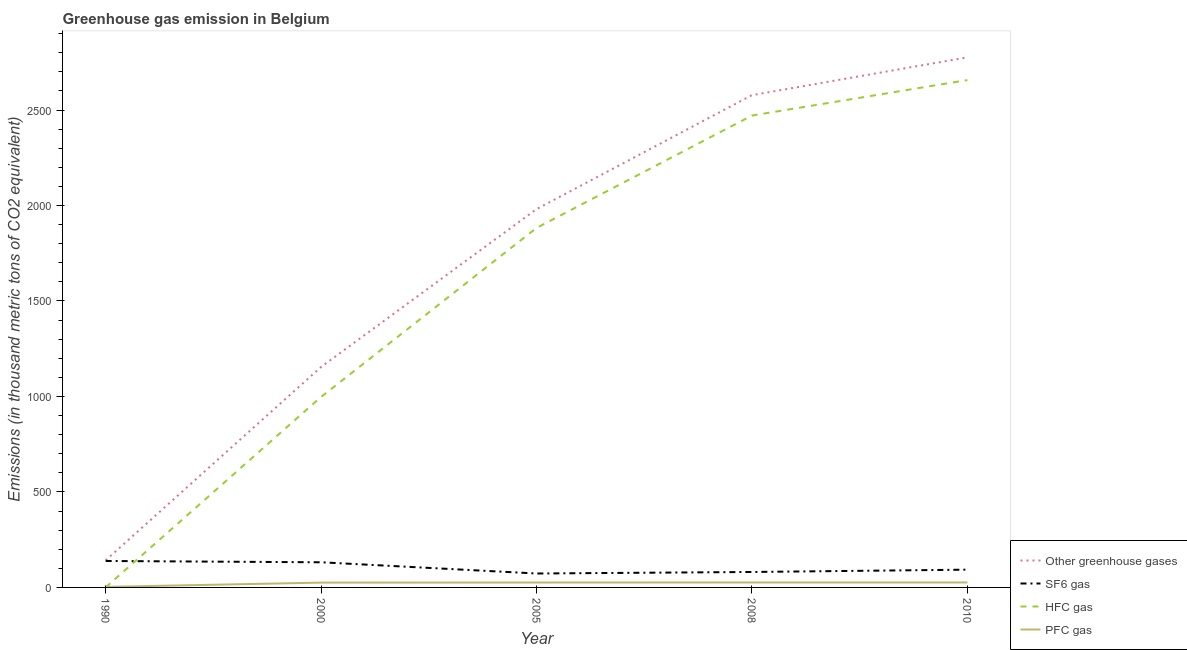How many different coloured lines are there?
Your answer should be compact. 4. Across all years, what is the maximum emission of sf6 gas?
Provide a short and direct response. 138.5. Across all years, what is the minimum emission of hfc gas?
Your answer should be very brief. 0.5. What is the total emission of sf6 gas in the graph?
Your answer should be very brief. 517. What is the difference between the emission of greenhouse gases in 2005 and that in 2008?
Offer a terse response. -596.8. What is the difference between the emission of pfc gas in 2005 and the emission of sf6 gas in 2010?
Offer a very short reply. -67.3. What is the average emission of pfc gas per year?
Keep it short and to the point. 21.16. In the year 1990, what is the difference between the emission of hfc gas and emission of greenhouse gases?
Make the answer very short. -141.4. In how many years, is the emission of greenhouse gases greater than 1600 thousand metric tons?
Provide a short and direct response. 3. What is the ratio of the emission of greenhouse gases in 2008 to that in 2010?
Your response must be concise. 0.93. Is the emission of greenhouse gases in 1990 less than that in 2005?
Offer a very short reply. Yes. What is the difference between the highest and the second highest emission of hfc gas?
Your answer should be very brief. 185.9. What is the difference between the highest and the lowest emission of greenhouse gases?
Make the answer very short. 2634.1. In how many years, is the emission of greenhouse gases greater than the average emission of greenhouse gases taken over all years?
Your answer should be very brief. 3. Is the sum of the emission of sf6 gas in 2005 and 2008 greater than the maximum emission of pfc gas across all years?
Your answer should be compact. Yes. Is it the case that in every year, the sum of the emission of pfc gas and emission of sf6 gas is greater than the sum of emission of greenhouse gases and emission of hfc gas?
Your answer should be compact. No. Is the emission of sf6 gas strictly less than the emission of pfc gas over the years?
Keep it short and to the point. No. How many lines are there?
Offer a terse response. 4. What is the difference between two consecutive major ticks on the Y-axis?
Offer a very short reply. 500. Does the graph contain grids?
Your answer should be compact. No. How are the legend labels stacked?
Keep it short and to the point. Vertical. What is the title of the graph?
Ensure brevity in your answer.  Greenhouse gas emission in Belgium. Does "Overall level" appear as one of the legend labels in the graph?
Give a very brief answer. No. What is the label or title of the X-axis?
Your answer should be very brief. Year. What is the label or title of the Y-axis?
Offer a terse response. Emissions (in thousand metric tons of CO2 equivalent). What is the Emissions (in thousand metric tons of CO2 equivalent) in Other greenhouse gases in 1990?
Ensure brevity in your answer.  141.9. What is the Emissions (in thousand metric tons of CO2 equivalent) of SF6 gas in 1990?
Provide a short and direct response. 138.5. What is the Emissions (in thousand metric tons of CO2 equivalent) of PFC gas in 1990?
Your response must be concise. 2.9. What is the Emissions (in thousand metric tons of CO2 equivalent) in Other greenhouse gases in 2000?
Your answer should be compact. 1154.6. What is the Emissions (in thousand metric tons of CO2 equivalent) in SF6 gas in 2000?
Your response must be concise. 131.7. What is the Emissions (in thousand metric tons of CO2 equivalent) of HFC gas in 2000?
Offer a very short reply. 997.7. What is the Emissions (in thousand metric tons of CO2 equivalent) of PFC gas in 2000?
Your response must be concise. 25.2. What is the Emissions (in thousand metric tons of CO2 equivalent) of Other greenhouse gases in 2005?
Ensure brevity in your answer.  1981.2. What is the Emissions (in thousand metric tons of CO2 equivalent) in SF6 gas in 2005?
Your answer should be very brief. 72.9. What is the Emissions (in thousand metric tons of CO2 equivalent) in HFC gas in 2005?
Keep it short and to the point. 1882.6. What is the Emissions (in thousand metric tons of CO2 equivalent) in PFC gas in 2005?
Provide a short and direct response. 25.7. What is the Emissions (in thousand metric tons of CO2 equivalent) in Other greenhouse gases in 2008?
Give a very brief answer. 2578. What is the Emissions (in thousand metric tons of CO2 equivalent) in SF6 gas in 2008?
Provide a short and direct response. 80.9. What is the Emissions (in thousand metric tons of CO2 equivalent) of HFC gas in 2008?
Your response must be concise. 2471.1. What is the Emissions (in thousand metric tons of CO2 equivalent) of Other greenhouse gases in 2010?
Ensure brevity in your answer.  2776. What is the Emissions (in thousand metric tons of CO2 equivalent) of SF6 gas in 2010?
Provide a succinct answer. 93. What is the Emissions (in thousand metric tons of CO2 equivalent) in HFC gas in 2010?
Ensure brevity in your answer.  2657. Across all years, what is the maximum Emissions (in thousand metric tons of CO2 equivalent) of Other greenhouse gases?
Provide a short and direct response. 2776. Across all years, what is the maximum Emissions (in thousand metric tons of CO2 equivalent) of SF6 gas?
Ensure brevity in your answer.  138.5. Across all years, what is the maximum Emissions (in thousand metric tons of CO2 equivalent) of HFC gas?
Provide a short and direct response. 2657. Across all years, what is the maximum Emissions (in thousand metric tons of CO2 equivalent) in PFC gas?
Your answer should be very brief. 26. Across all years, what is the minimum Emissions (in thousand metric tons of CO2 equivalent) of Other greenhouse gases?
Offer a terse response. 141.9. Across all years, what is the minimum Emissions (in thousand metric tons of CO2 equivalent) in SF6 gas?
Offer a terse response. 72.9. What is the total Emissions (in thousand metric tons of CO2 equivalent) in Other greenhouse gases in the graph?
Give a very brief answer. 8631.7. What is the total Emissions (in thousand metric tons of CO2 equivalent) of SF6 gas in the graph?
Ensure brevity in your answer.  517. What is the total Emissions (in thousand metric tons of CO2 equivalent) in HFC gas in the graph?
Provide a succinct answer. 8008.9. What is the total Emissions (in thousand metric tons of CO2 equivalent) of PFC gas in the graph?
Provide a short and direct response. 105.8. What is the difference between the Emissions (in thousand metric tons of CO2 equivalent) of Other greenhouse gases in 1990 and that in 2000?
Your answer should be very brief. -1012.7. What is the difference between the Emissions (in thousand metric tons of CO2 equivalent) of HFC gas in 1990 and that in 2000?
Your answer should be compact. -997.2. What is the difference between the Emissions (in thousand metric tons of CO2 equivalent) of PFC gas in 1990 and that in 2000?
Give a very brief answer. -22.3. What is the difference between the Emissions (in thousand metric tons of CO2 equivalent) in Other greenhouse gases in 1990 and that in 2005?
Provide a short and direct response. -1839.3. What is the difference between the Emissions (in thousand metric tons of CO2 equivalent) of SF6 gas in 1990 and that in 2005?
Provide a short and direct response. 65.6. What is the difference between the Emissions (in thousand metric tons of CO2 equivalent) in HFC gas in 1990 and that in 2005?
Keep it short and to the point. -1882.1. What is the difference between the Emissions (in thousand metric tons of CO2 equivalent) in PFC gas in 1990 and that in 2005?
Your response must be concise. -22.8. What is the difference between the Emissions (in thousand metric tons of CO2 equivalent) in Other greenhouse gases in 1990 and that in 2008?
Give a very brief answer. -2436.1. What is the difference between the Emissions (in thousand metric tons of CO2 equivalent) of SF6 gas in 1990 and that in 2008?
Provide a succinct answer. 57.6. What is the difference between the Emissions (in thousand metric tons of CO2 equivalent) of HFC gas in 1990 and that in 2008?
Keep it short and to the point. -2470.6. What is the difference between the Emissions (in thousand metric tons of CO2 equivalent) of PFC gas in 1990 and that in 2008?
Provide a short and direct response. -23.1. What is the difference between the Emissions (in thousand metric tons of CO2 equivalent) of Other greenhouse gases in 1990 and that in 2010?
Your answer should be compact. -2634.1. What is the difference between the Emissions (in thousand metric tons of CO2 equivalent) of SF6 gas in 1990 and that in 2010?
Keep it short and to the point. 45.5. What is the difference between the Emissions (in thousand metric tons of CO2 equivalent) in HFC gas in 1990 and that in 2010?
Your answer should be very brief. -2656.5. What is the difference between the Emissions (in thousand metric tons of CO2 equivalent) in PFC gas in 1990 and that in 2010?
Ensure brevity in your answer.  -23.1. What is the difference between the Emissions (in thousand metric tons of CO2 equivalent) of Other greenhouse gases in 2000 and that in 2005?
Keep it short and to the point. -826.6. What is the difference between the Emissions (in thousand metric tons of CO2 equivalent) in SF6 gas in 2000 and that in 2005?
Keep it short and to the point. 58.8. What is the difference between the Emissions (in thousand metric tons of CO2 equivalent) in HFC gas in 2000 and that in 2005?
Your answer should be very brief. -884.9. What is the difference between the Emissions (in thousand metric tons of CO2 equivalent) in Other greenhouse gases in 2000 and that in 2008?
Offer a terse response. -1423.4. What is the difference between the Emissions (in thousand metric tons of CO2 equivalent) in SF6 gas in 2000 and that in 2008?
Make the answer very short. 50.8. What is the difference between the Emissions (in thousand metric tons of CO2 equivalent) in HFC gas in 2000 and that in 2008?
Your answer should be very brief. -1473.4. What is the difference between the Emissions (in thousand metric tons of CO2 equivalent) of PFC gas in 2000 and that in 2008?
Give a very brief answer. -0.8. What is the difference between the Emissions (in thousand metric tons of CO2 equivalent) in Other greenhouse gases in 2000 and that in 2010?
Provide a succinct answer. -1621.4. What is the difference between the Emissions (in thousand metric tons of CO2 equivalent) in SF6 gas in 2000 and that in 2010?
Keep it short and to the point. 38.7. What is the difference between the Emissions (in thousand metric tons of CO2 equivalent) of HFC gas in 2000 and that in 2010?
Provide a short and direct response. -1659.3. What is the difference between the Emissions (in thousand metric tons of CO2 equivalent) of Other greenhouse gases in 2005 and that in 2008?
Your response must be concise. -596.8. What is the difference between the Emissions (in thousand metric tons of CO2 equivalent) in SF6 gas in 2005 and that in 2008?
Offer a very short reply. -8. What is the difference between the Emissions (in thousand metric tons of CO2 equivalent) of HFC gas in 2005 and that in 2008?
Your answer should be compact. -588.5. What is the difference between the Emissions (in thousand metric tons of CO2 equivalent) of Other greenhouse gases in 2005 and that in 2010?
Offer a terse response. -794.8. What is the difference between the Emissions (in thousand metric tons of CO2 equivalent) of SF6 gas in 2005 and that in 2010?
Provide a succinct answer. -20.1. What is the difference between the Emissions (in thousand metric tons of CO2 equivalent) of HFC gas in 2005 and that in 2010?
Offer a terse response. -774.4. What is the difference between the Emissions (in thousand metric tons of CO2 equivalent) of PFC gas in 2005 and that in 2010?
Your answer should be very brief. -0.3. What is the difference between the Emissions (in thousand metric tons of CO2 equivalent) of Other greenhouse gases in 2008 and that in 2010?
Your answer should be compact. -198. What is the difference between the Emissions (in thousand metric tons of CO2 equivalent) in HFC gas in 2008 and that in 2010?
Your response must be concise. -185.9. What is the difference between the Emissions (in thousand metric tons of CO2 equivalent) of PFC gas in 2008 and that in 2010?
Offer a terse response. 0. What is the difference between the Emissions (in thousand metric tons of CO2 equivalent) in Other greenhouse gases in 1990 and the Emissions (in thousand metric tons of CO2 equivalent) in HFC gas in 2000?
Give a very brief answer. -855.8. What is the difference between the Emissions (in thousand metric tons of CO2 equivalent) of Other greenhouse gases in 1990 and the Emissions (in thousand metric tons of CO2 equivalent) of PFC gas in 2000?
Make the answer very short. 116.7. What is the difference between the Emissions (in thousand metric tons of CO2 equivalent) in SF6 gas in 1990 and the Emissions (in thousand metric tons of CO2 equivalent) in HFC gas in 2000?
Give a very brief answer. -859.2. What is the difference between the Emissions (in thousand metric tons of CO2 equivalent) of SF6 gas in 1990 and the Emissions (in thousand metric tons of CO2 equivalent) of PFC gas in 2000?
Keep it short and to the point. 113.3. What is the difference between the Emissions (in thousand metric tons of CO2 equivalent) of HFC gas in 1990 and the Emissions (in thousand metric tons of CO2 equivalent) of PFC gas in 2000?
Offer a terse response. -24.7. What is the difference between the Emissions (in thousand metric tons of CO2 equivalent) of Other greenhouse gases in 1990 and the Emissions (in thousand metric tons of CO2 equivalent) of HFC gas in 2005?
Ensure brevity in your answer.  -1740.7. What is the difference between the Emissions (in thousand metric tons of CO2 equivalent) in Other greenhouse gases in 1990 and the Emissions (in thousand metric tons of CO2 equivalent) in PFC gas in 2005?
Give a very brief answer. 116.2. What is the difference between the Emissions (in thousand metric tons of CO2 equivalent) in SF6 gas in 1990 and the Emissions (in thousand metric tons of CO2 equivalent) in HFC gas in 2005?
Provide a short and direct response. -1744.1. What is the difference between the Emissions (in thousand metric tons of CO2 equivalent) in SF6 gas in 1990 and the Emissions (in thousand metric tons of CO2 equivalent) in PFC gas in 2005?
Offer a very short reply. 112.8. What is the difference between the Emissions (in thousand metric tons of CO2 equivalent) of HFC gas in 1990 and the Emissions (in thousand metric tons of CO2 equivalent) of PFC gas in 2005?
Give a very brief answer. -25.2. What is the difference between the Emissions (in thousand metric tons of CO2 equivalent) in Other greenhouse gases in 1990 and the Emissions (in thousand metric tons of CO2 equivalent) in HFC gas in 2008?
Provide a short and direct response. -2329.2. What is the difference between the Emissions (in thousand metric tons of CO2 equivalent) in Other greenhouse gases in 1990 and the Emissions (in thousand metric tons of CO2 equivalent) in PFC gas in 2008?
Offer a terse response. 115.9. What is the difference between the Emissions (in thousand metric tons of CO2 equivalent) in SF6 gas in 1990 and the Emissions (in thousand metric tons of CO2 equivalent) in HFC gas in 2008?
Provide a short and direct response. -2332.6. What is the difference between the Emissions (in thousand metric tons of CO2 equivalent) in SF6 gas in 1990 and the Emissions (in thousand metric tons of CO2 equivalent) in PFC gas in 2008?
Offer a terse response. 112.5. What is the difference between the Emissions (in thousand metric tons of CO2 equivalent) of HFC gas in 1990 and the Emissions (in thousand metric tons of CO2 equivalent) of PFC gas in 2008?
Your answer should be compact. -25.5. What is the difference between the Emissions (in thousand metric tons of CO2 equivalent) in Other greenhouse gases in 1990 and the Emissions (in thousand metric tons of CO2 equivalent) in SF6 gas in 2010?
Keep it short and to the point. 48.9. What is the difference between the Emissions (in thousand metric tons of CO2 equivalent) in Other greenhouse gases in 1990 and the Emissions (in thousand metric tons of CO2 equivalent) in HFC gas in 2010?
Give a very brief answer. -2515.1. What is the difference between the Emissions (in thousand metric tons of CO2 equivalent) in Other greenhouse gases in 1990 and the Emissions (in thousand metric tons of CO2 equivalent) in PFC gas in 2010?
Your answer should be compact. 115.9. What is the difference between the Emissions (in thousand metric tons of CO2 equivalent) in SF6 gas in 1990 and the Emissions (in thousand metric tons of CO2 equivalent) in HFC gas in 2010?
Give a very brief answer. -2518.5. What is the difference between the Emissions (in thousand metric tons of CO2 equivalent) in SF6 gas in 1990 and the Emissions (in thousand metric tons of CO2 equivalent) in PFC gas in 2010?
Ensure brevity in your answer.  112.5. What is the difference between the Emissions (in thousand metric tons of CO2 equivalent) of HFC gas in 1990 and the Emissions (in thousand metric tons of CO2 equivalent) of PFC gas in 2010?
Offer a very short reply. -25.5. What is the difference between the Emissions (in thousand metric tons of CO2 equivalent) in Other greenhouse gases in 2000 and the Emissions (in thousand metric tons of CO2 equivalent) in SF6 gas in 2005?
Your answer should be compact. 1081.7. What is the difference between the Emissions (in thousand metric tons of CO2 equivalent) in Other greenhouse gases in 2000 and the Emissions (in thousand metric tons of CO2 equivalent) in HFC gas in 2005?
Make the answer very short. -728. What is the difference between the Emissions (in thousand metric tons of CO2 equivalent) in Other greenhouse gases in 2000 and the Emissions (in thousand metric tons of CO2 equivalent) in PFC gas in 2005?
Make the answer very short. 1128.9. What is the difference between the Emissions (in thousand metric tons of CO2 equivalent) in SF6 gas in 2000 and the Emissions (in thousand metric tons of CO2 equivalent) in HFC gas in 2005?
Offer a terse response. -1750.9. What is the difference between the Emissions (in thousand metric tons of CO2 equivalent) of SF6 gas in 2000 and the Emissions (in thousand metric tons of CO2 equivalent) of PFC gas in 2005?
Give a very brief answer. 106. What is the difference between the Emissions (in thousand metric tons of CO2 equivalent) in HFC gas in 2000 and the Emissions (in thousand metric tons of CO2 equivalent) in PFC gas in 2005?
Provide a succinct answer. 972. What is the difference between the Emissions (in thousand metric tons of CO2 equivalent) in Other greenhouse gases in 2000 and the Emissions (in thousand metric tons of CO2 equivalent) in SF6 gas in 2008?
Provide a short and direct response. 1073.7. What is the difference between the Emissions (in thousand metric tons of CO2 equivalent) in Other greenhouse gases in 2000 and the Emissions (in thousand metric tons of CO2 equivalent) in HFC gas in 2008?
Offer a terse response. -1316.5. What is the difference between the Emissions (in thousand metric tons of CO2 equivalent) in Other greenhouse gases in 2000 and the Emissions (in thousand metric tons of CO2 equivalent) in PFC gas in 2008?
Provide a succinct answer. 1128.6. What is the difference between the Emissions (in thousand metric tons of CO2 equivalent) of SF6 gas in 2000 and the Emissions (in thousand metric tons of CO2 equivalent) of HFC gas in 2008?
Provide a short and direct response. -2339.4. What is the difference between the Emissions (in thousand metric tons of CO2 equivalent) of SF6 gas in 2000 and the Emissions (in thousand metric tons of CO2 equivalent) of PFC gas in 2008?
Offer a terse response. 105.7. What is the difference between the Emissions (in thousand metric tons of CO2 equivalent) of HFC gas in 2000 and the Emissions (in thousand metric tons of CO2 equivalent) of PFC gas in 2008?
Your answer should be very brief. 971.7. What is the difference between the Emissions (in thousand metric tons of CO2 equivalent) of Other greenhouse gases in 2000 and the Emissions (in thousand metric tons of CO2 equivalent) of SF6 gas in 2010?
Ensure brevity in your answer.  1061.6. What is the difference between the Emissions (in thousand metric tons of CO2 equivalent) in Other greenhouse gases in 2000 and the Emissions (in thousand metric tons of CO2 equivalent) in HFC gas in 2010?
Keep it short and to the point. -1502.4. What is the difference between the Emissions (in thousand metric tons of CO2 equivalent) of Other greenhouse gases in 2000 and the Emissions (in thousand metric tons of CO2 equivalent) of PFC gas in 2010?
Give a very brief answer. 1128.6. What is the difference between the Emissions (in thousand metric tons of CO2 equivalent) of SF6 gas in 2000 and the Emissions (in thousand metric tons of CO2 equivalent) of HFC gas in 2010?
Offer a very short reply. -2525.3. What is the difference between the Emissions (in thousand metric tons of CO2 equivalent) in SF6 gas in 2000 and the Emissions (in thousand metric tons of CO2 equivalent) in PFC gas in 2010?
Offer a very short reply. 105.7. What is the difference between the Emissions (in thousand metric tons of CO2 equivalent) in HFC gas in 2000 and the Emissions (in thousand metric tons of CO2 equivalent) in PFC gas in 2010?
Make the answer very short. 971.7. What is the difference between the Emissions (in thousand metric tons of CO2 equivalent) of Other greenhouse gases in 2005 and the Emissions (in thousand metric tons of CO2 equivalent) of SF6 gas in 2008?
Your response must be concise. 1900.3. What is the difference between the Emissions (in thousand metric tons of CO2 equivalent) of Other greenhouse gases in 2005 and the Emissions (in thousand metric tons of CO2 equivalent) of HFC gas in 2008?
Offer a very short reply. -489.9. What is the difference between the Emissions (in thousand metric tons of CO2 equivalent) of Other greenhouse gases in 2005 and the Emissions (in thousand metric tons of CO2 equivalent) of PFC gas in 2008?
Your response must be concise. 1955.2. What is the difference between the Emissions (in thousand metric tons of CO2 equivalent) of SF6 gas in 2005 and the Emissions (in thousand metric tons of CO2 equivalent) of HFC gas in 2008?
Ensure brevity in your answer.  -2398.2. What is the difference between the Emissions (in thousand metric tons of CO2 equivalent) of SF6 gas in 2005 and the Emissions (in thousand metric tons of CO2 equivalent) of PFC gas in 2008?
Your answer should be very brief. 46.9. What is the difference between the Emissions (in thousand metric tons of CO2 equivalent) of HFC gas in 2005 and the Emissions (in thousand metric tons of CO2 equivalent) of PFC gas in 2008?
Your answer should be very brief. 1856.6. What is the difference between the Emissions (in thousand metric tons of CO2 equivalent) of Other greenhouse gases in 2005 and the Emissions (in thousand metric tons of CO2 equivalent) of SF6 gas in 2010?
Offer a terse response. 1888.2. What is the difference between the Emissions (in thousand metric tons of CO2 equivalent) in Other greenhouse gases in 2005 and the Emissions (in thousand metric tons of CO2 equivalent) in HFC gas in 2010?
Provide a succinct answer. -675.8. What is the difference between the Emissions (in thousand metric tons of CO2 equivalent) of Other greenhouse gases in 2005 and the Emissions (in thousand metric tons of CO2 equivalent) of PFC gas in 2010?
Keep it short and to the point. 1955.2. What is the difference between the Emissions (in thousand metric tons of CO2 equivalent) in SF6 gas in 2005 and the Emissions (in thousand metric tons of CO2 equivalent) in HFC gas in 2010?
Provide a succinct answer. -2584.1. What is the difference between the Emissions (in thousand metric tons of CO2 equivalent) of SF6 gas in 2005 and the Emissions (in thousand metric tons of CO2 equivalent) of PFC gas in 2010?
Make the answer very short. 46.9. What is the difference between the Emissions (in thousand metric tons of CO2 equivalent) of HFC gas in 2005 and the Emissions (in thousand metric tons of CO2 equivalent) of PFC gas in 2010?
Give a very brief answer. 1856.6. What is the difference between the Emissions (in thousand metric tons of CO2 equivalent) in Other greenhouse gases in 2008 and the Emissions (in thousand metric tons of CO2 equivalent) in SF6 gas in 2010?
Offer a terse response. 2485. What is the difference between the Emissions (in thousand metric tons of CO2 equivalent) in Other greenhouse gases in 2008 and the Emissions (in thousand metric tons of CO2 equivalent) in HFC gas in 2010?
Offer a terse response. -79. What is the difference between the Emissions (in thousand metric tons of CO2 equivalent) in Other greenhouse gases in 2008 and the Emissions (in thousand metric tons of CO2 equivalent) in PFC gas in 2010?
Your answer should be compact. 2552. What is the difference between the Emissions (in thousand metric tons of CO2 equivalent) of SF6 gas in 2008 and the Emissions (in thousand metric tons of CO2 equivalent) of HFC gas in 2010?
Provide a succinct answer. -2576.1. What is the difference between the Emissions (in thousand metric tons of CO2 equivalent) of SF6 gas in 2008 and the Emissions (in thousand metric tons of CO2 equivalent) of PFC gas in 2010?
Provide a short and direct response. 54.9. What is the difference between the Emissions (in thousand metric tons of CO2 equivalent) in HFC gas in 2008 and the Emissions (in thousand metric tons of CO2 equivalent) in PFC gas in 2010?
Your answer should be compact. 2445.1. What is the average Emissions (in thousand metric tons of CO2 equivalent) in Other greenhouse gases per year?
Make the answer very short. 1726.34. What is the average Emissions (in thousand metric tons of CO2 equivalent) in SF6 gas per year?
Your answer should be compact. 103.4. What is the average Emissions (in thousand metric tons of CO2 equivalent) of HFC gas per year?
Ensure brevity in your answer.  1601.78. What is the average Emissions (in thousand metric tons of CO2 equivalent) in PFC gas per year?
Your answer should be compact. 21.16. In the year 1990, what is the difference between the Emissions (in thousand metric tons of CO2 equivalent) in Other greenhouse gases and Emissions (in thousand metric tons of CO2 equivalent) in HFC gas?
Offer a very short reply. 141.4. In the year 1990, what is the difference between the Emissions (in thousand metric tons of CO2 equivalent) of Other greenhouse gases and Emissions (in thousand metric tons of CO2 equivalent) of PFC gas?
Offer a very short reply. 139. In the year 1990, what is the difference between the Emissions (in thousand metric tons of CO2 equivalent) in SF6 gas and Emissions (in thousand metric tons of CO2 equivalent) in HFC gas?
Keep it short and to the point. 138. In the year 1990, what is the difference between the Emissions (in thousand metric tons of CO2 equivalent) of SF6 gas and Emissions (in thousand metric tons of CO2 equivalent) of PFC gas?
Provide a short and direct response. 135.6. In the year 1990, what is the difference between the Emissions (in thousand metric tons of CO2 equivalent) in HFC gas and Emissions (in thousand metric tons of CO2 equivalent) in PFC gas?
Ensure brevity in your answer.  -2.4. In the year 2000, what is the difference between the Emissions (in thousand metric tons of CO2 equivalent) in Other greenhouse gases and Emissions (in thousand metric tons of CO2 equivalent) in SF6 gas?
Your answer should be very brief. 1022.9. In the year 2000, what is the difference between the Emissions (in thousand metric tons of CO2 equivalent) in Other greenhouse gases and Emissions (in thousand metric tons of CO2 equivalent) in HFC gas?
Offer a terse response. 156.9. In the year 2000, what is the difference between the Emissions (in thousand metric tons of CO2 equivalent) in Other greenhouse gases and Emissions (in thousand metric tons of CO2 equivalent) in PFC gas?
Your response must be concise. 1129.4. In the year 2000, what is the difference between the Emissions (in thousand metric tons of CO2 equivalent) of SF6 gas and Emissions (in thousand metric tons of CO2 equivalent) of HFC gas?
Provide a succinct answer. -866. In the year 2000, what is the difference between the Emissions (in thousand metric tons of CO2 equivalent) in SF6 gas and Emissions (in thousand metric tons of CO2 equivalent) in PFC gas?
Provide a short and direct response. 106.5. In the year 2000, what is the difference between the Emissions (in thousand metric tons of CO2 equivalent) of HFC gas and Emissions (in thousand metric tons of CO2 equivalent) of PFC gas?
Your answer should be very brief. 972.5. In the year 2005, what is the difference between the Emissions (in thousand metric tons of CO2 equivalent) in Other greenhouse gases and Emissions (in thousand metric tons of CO2 equivalent) in SF6 gas?
Provide a short and direct response. 1908.3. In the year 2005, what is the difference between the Emissions (in thousand metric tons of CO2 equivalent) of Other greenhouse gases and Emissions (in thousand metric tons of CO2 equivalent) of HFC gas?
Provide a succinct answer. 98.6. In the year 2005, what is the difference between the Emissions (in thousand metric tons of CO2 equivalent) of Other greenhouse gases and Emissions (in thousand metric tons of CO2 equivalent) of PFC gas?
Give a very brief answer. 1955.5. In the year 2005, what is the difference between the Emissions (in thousand metric tons of CO2 equivalent) of SF6 gas and Emissions (in thousand metric tons of CO2 equivalent) of HFC gas?
Make the answer very short. -1809.7. In the year 2005, what is the difference between the Emissions (in thousand metric tons of CO2 equivalent) of SF6 gas and Emissions (in thousand metric tons of CO2 equivalent) of PFC gas?
Keep it short and to the point. 47.2. In the year 2005, what is the difference between the Emissions (in thousand metric tons of CO2 equivalent) in HFC gas and Emissions (in thousand metric tons of CO2 equivalent) in PFC gas?
Your response must be concise. 1856.9. In the year 2008, what is the difference between the Emissions (in thousand metric tons of CO2 equivalent) of Other greenhouse gases and Emissions (in thousand metric tons of CO2 equivalent) of SF6 gas?
Give a very brief answer. 2497.1. In the year 2008, what is the difference between the Emissions (in thousand metric tons of CO2 equivalent) of Other greenhouse gases and Emissions (in thousand metric tons of CO2 equivalent) of HFC gas?
Keep it short and to the point. 106.9. In the year 2008, what is the difference between the Emissions (in thousand metric tons of CO2 equivalent) of Other greenhouse gases and Emissions (in thousand metric tons of CO2 equivalent) of PFC gas?
Provide a succinct answer. 2552. In the year 2008, what is the difference between the Emissions (in thousand metric tons of CO2 equivalent) in SF6 gas and Emissions (in thousand metric tons of CO2 equivalent) in HFC gas?
Keep it short and to the point. -2390.2. In the year 2008, what is the difference between the Emissions (in thousand metric tons of CO2 equivalent) of SF6 gas and Emissions (in thousand metric tons of CO2 equivalent) of PFC gas?
Make the answer very short. 54.9. In the year 2008, what is the difference between the Emissions (in thousand metric tons of CO2 equivalent) of HFC gas and Emissions (in thousand metric tons of CO2 equivalent) of PFC gas?
Provide a short and direct response. 2445.1. In the year 2010, what is the difference between the Emissions (in thousand metric tons of CO2 equivalent) in Other greenhouse gases and Emissions (in thousand metric tons of CO2 equivalent) in SF6 gas?
Offer a terse response. 2683. In the year 2010, what is the difference between the Emissions (in thousand metric tons of CO2 equivalent) in Other greenhouse gases and Emissions (in thousand metric tons of CO2 equivalent) in HFC gas?
Make the answer very short. 119. In the year 2010, what is the difference between the Emissions (in thousand metric tons of CO2 equivalent) of Other greenhouse gases and Emissions (in thousand metric tons of CO2 equivalent) of PFC gas?
Your answer should be compact. 2750. In the year 2010, what is the difference between the Emissions (in thousand metric tons of CO2 equivalent) of SF6 gas and Emissions (in thousand metric tons of CO2 equivalent) of HFC gas?
Offer a very short reply. -2564. In the year 2010, what is the difference between the Emissions (in thousand metric tons of CO2 equivalent) in SF6 gas and Emissions (in thousand metric tons of CO2 equivalent) in PFC gas?
Keep it short and to the point. 67. In the year 2010, what is the difference between the Emissions (in thousand metric tons of CO2 equivalent) of HFC gas and Emissions (in thousand metric tons of CO2 equivalent) of PFC gas?
Provide a short and direct response. 2631. What is the ratio of the Emissions (in thousand metric tons of CO2 equivalent) of Other greenhouse gases in 1990 to that in 2000?
Ensure brevity in your answer.  0.12. What is the ratio of the Emissions (in thousand metric tons of CO2 equivalent) in SF6 gas in 1990 to that in 2000?
Your answer should be compact. 1.05. What is the ratio of the Emissions (in thousand metric tons of CO2 equivalent) in HFC gas in 1990 to that in 2000?
Your answer should be very brief. 0. What is the ratio of the Emissions (in thousand metric tons of CO2 equivalent) in PFC gas in 1990 to that in 2000?
Provide a short and direct response. 0.12. What is the ratio of the Emissions (in thousand metric tons of CO2 equivalent) in Other greenhouse gases in 1990 to that in 2005?
Your response must be concise. 0.07. What is the ratio of the Emissions (in thousand metric tons of CO2 equivalent) in SF6 gas in 1990 to that in 2005?
Your answer should be compact. 1.9. What is the ratio of the Emissions (in thousand metric tons of CO2 equivalent) in PFC gas in 1990 to that in 2005?
Ensure brevity in your answer.  0.11. What is the ratio of the Emissions (in thousand metric tons of CO2 equivalent) of Other greenhouse gases in 1990 to that in 2008?
Give a very brief answer. 0.06. What is the ratio of the Emissions (in thousand metric tons of CO2 equivalent) of SF6 gas in 1990 to that in 2008?
Offer a terse response. 1.71. What is the ratio of the Emissions (in thousand metric tons of CO2 equivalent) of HFC gas in 1990 to that in 2008?
Your response must be concise. 0. What is the ratio of the Emissions (in thousand metric tons of CO2 equivalent) of PFC gas in 1990 to that in 2008?
Your answer should be very brief. 0.11. What is the ratio of the Emissions (in thousand metric tons of CO2 equivalent) in Other greenhouse gases in 1990 to that in 2010?
Ensure brevity in your answer.  0.05. What is the ratio of the Emissions (in thousand metric tons of CO2 equivalent) in SF6 gas in 1990 to that in 2010?
Make the answer very short. 1.49. What is the ratio of the Emissions (in thousand metric tons of CO2 equivalent) of HFC gas in 1990 to that in 2010?
Your answer should be very brief. 0. What is the ratio of the Emissions (in thousand metric tons of CO2 equivalent) in PFC gas in 1990 to that in 2010?
Provide a succinct answer. 0.11. What is the ratio of the Emissions (in thousand metric tons of CO2 equivalent) in Other greenhouse gases in 2000 to that in 2005?
Make the answer very short. 0.58. What is the ratio of the Emissions (in thousand metric tons of CO2 equivalent) of SF6 gas in 2000 to that in 2005?
Provide a short and direct response. 1.81. What is the ratio of the Emissions (in thousand metric tons of CO2 equivalent) in HFC gas in 2000 to that in 2005?
Keep it short and to the point. 0.53. What is the ratio of the Emissions (in thousand metric tons of CO2 equivalent) in PFC gas in 2000 to that in 2005?
Offer a very short reply. 0.98. What is the ratio of the Emissions (in thousand metric tons of CO2 equivalent) in Other greenhouse gases in 2000 to that in 2008?
Provide a short and direct response. 0.45. What is the ratio of the Emissions (in thousand metric tons of CO2 equivalent) of SF6 gas in 2000 to that in 2008?
Provide a short and direct response. 1.63. What is the ratio of the Emissions (in thousand metric tons of CO2 equivalent) of HFC gas in 2000 to that in 2008?
Provide a short and direct response. 0.4. What is the ratio of the Emissions (in thousand metric tons of CO2 equivalent) in PFC gas in 2000 to that in 2008?
Make the answer very short. 0.97. What is the ratio of the Emissions (in thousand metric tons of CO2 equivalent) in Other greenhouse gases in 2000 to that in 2010?
Your response must be concise. 0.42. What is the ratio of the Emissions (in thousand metric tons of CO2 equivalent) of SF6 gas in 2000 to that in 2010?
Provide a short and direct response. 1.42. What is the ratio of the Emissions (in thousand metric tons of CO2 equivalent) in HFC gas in 2000 to that in 2010?
Make the answer very short. 0.38. What is the ratio of the Emissions (in thousand metric tons of CO2 equivalent) of PFC gas in 2000 to that in 2010?
Make the answer very short. 0.97. What is the ratio of the Emissions (in thousand metric tons of CO2 equivalent) in Other greenhouse gases in 2005 to that in 2008?
Ensure brevity in your answer.  0.77. What is the ratio of the Emissions (in thousand metric tons of CO2 equivalent) of SF6 gas in 2005 to that in 2008?
Keep it short and to the point. 0.9. What is the ratio of the Emissions (in thousand metric tons of CO2 equivalent) of HFC gas in 2005 to that in 2008?
Your answer should be compact. 0.76. What is the ratio of the Emissions (in thousand metric tons of CO2 equivalent) in PFC gas in 2005 to that in 2008?
Keep it short and to the point. 0.99. What is the ratio of the Emissions (in thousand metric tons of CO2 equivalent) in Other greenhouse gases in 2005 to that in 2010?
Offer a very short reply. 0.71. What is the ratio of the Emissions (in thousand metric tons of CO2 equivalent) of SF6 gas in 2005 to that in 2010?
Keep it short and to the point. 0.78. What is the ratio of the Emissions (in thousand metric tons of CO2 equivalent) in HFC gas in 2005 to that in 2010?
Make the answer very short. 0.71. What is the ratio of the Emissions (in thousand metric tons of CO2 equivalent) in PFC gas in 2005 to that in 2010?
Keep it short and to the point. 0.99. What is the ratio of the Emissions (in thousand metric tons of CO2 equivalent) of Other greenhouse gases in 2008 to that in 2010?
Offer a terse response. 0.93. What is the ratio of the Emissions (in thousand metric tons of CO2 equivalent) of SF6 gas in 2008 to that in 2010?
Provide a succinct answer. 0.87. What is the ratio of the Emissions (in thousand metric tons of CO2 equivalent) of HFC gas in 2008 to that in 2010?
Provide a short and direct response. 0.93. What is the ratio of the Emissions (in thousand metric tons of CO2 equivalent) in PFC gas in 2008 to that in 2010?
Offer a very short reply. 1. What is the difference between the highest and the second highest Emissions (in thousand metric tons of CO2 equivalent) of Other greenhouse gases?
Your answer should be very brief. 198. What is the difference between the highest and the second highest Emissions (in thousand metric tons of CO2 equivalent) of HFC gas?
Keep it short and to the point. 185.9. What is the difference between the highest and the lowest Emissions (in thousand metric tons of CO2 equivalent) in Other greenhouse gases?
Provide a succinct answer. 2634.1. What is the difference between the highest and the lowest Emissions (in thousand metric tons of CO2 equivalent) in SF6 gas?
Provide a short and direct response. 65.6. What is the difference between the highest and the lowest Emissions (in thousand metric tons of CO2 equivalent) in HFC gas?
Ensure brevity in your answer.  2656.5. What is the difference between the highest and the lowest Emissions (in thousand metric tons of CO2 equivalent) of PFC gas?
Ensure brevity in your answer.  23.1. 